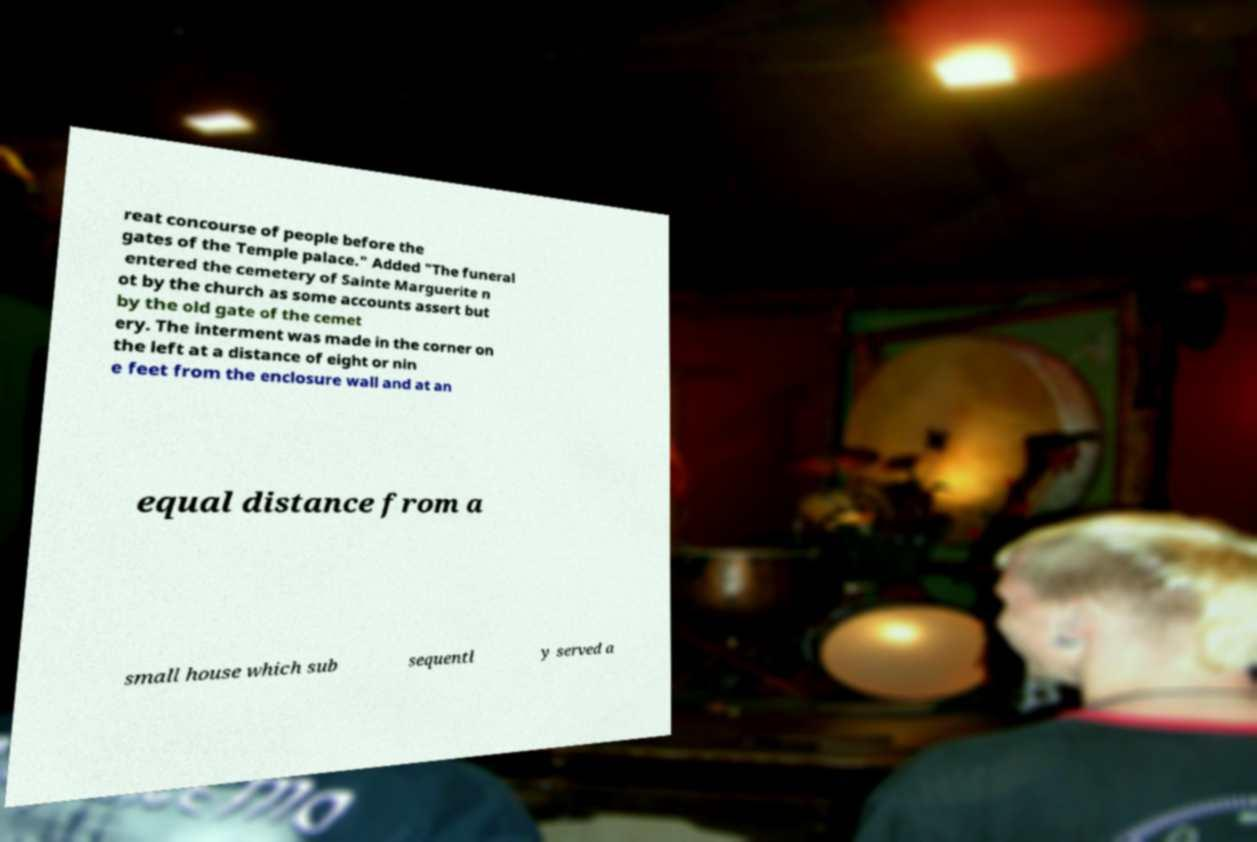Can you read and provide the text displayed in the image?This photo seems to have some interesting text. Can you extract and type it out for me? reat concourse of people before the gates of the Temple palace." Added "The funeral entered the cemetery of Sainte Marguerite n ot by the church as some accounts assert but by the old gate of the cemet ery. The interment was made in the corner on the left at a distance of eight or nin e feet from the enclosure wall and at an equal distance from a small house which sub sequentl y served a 